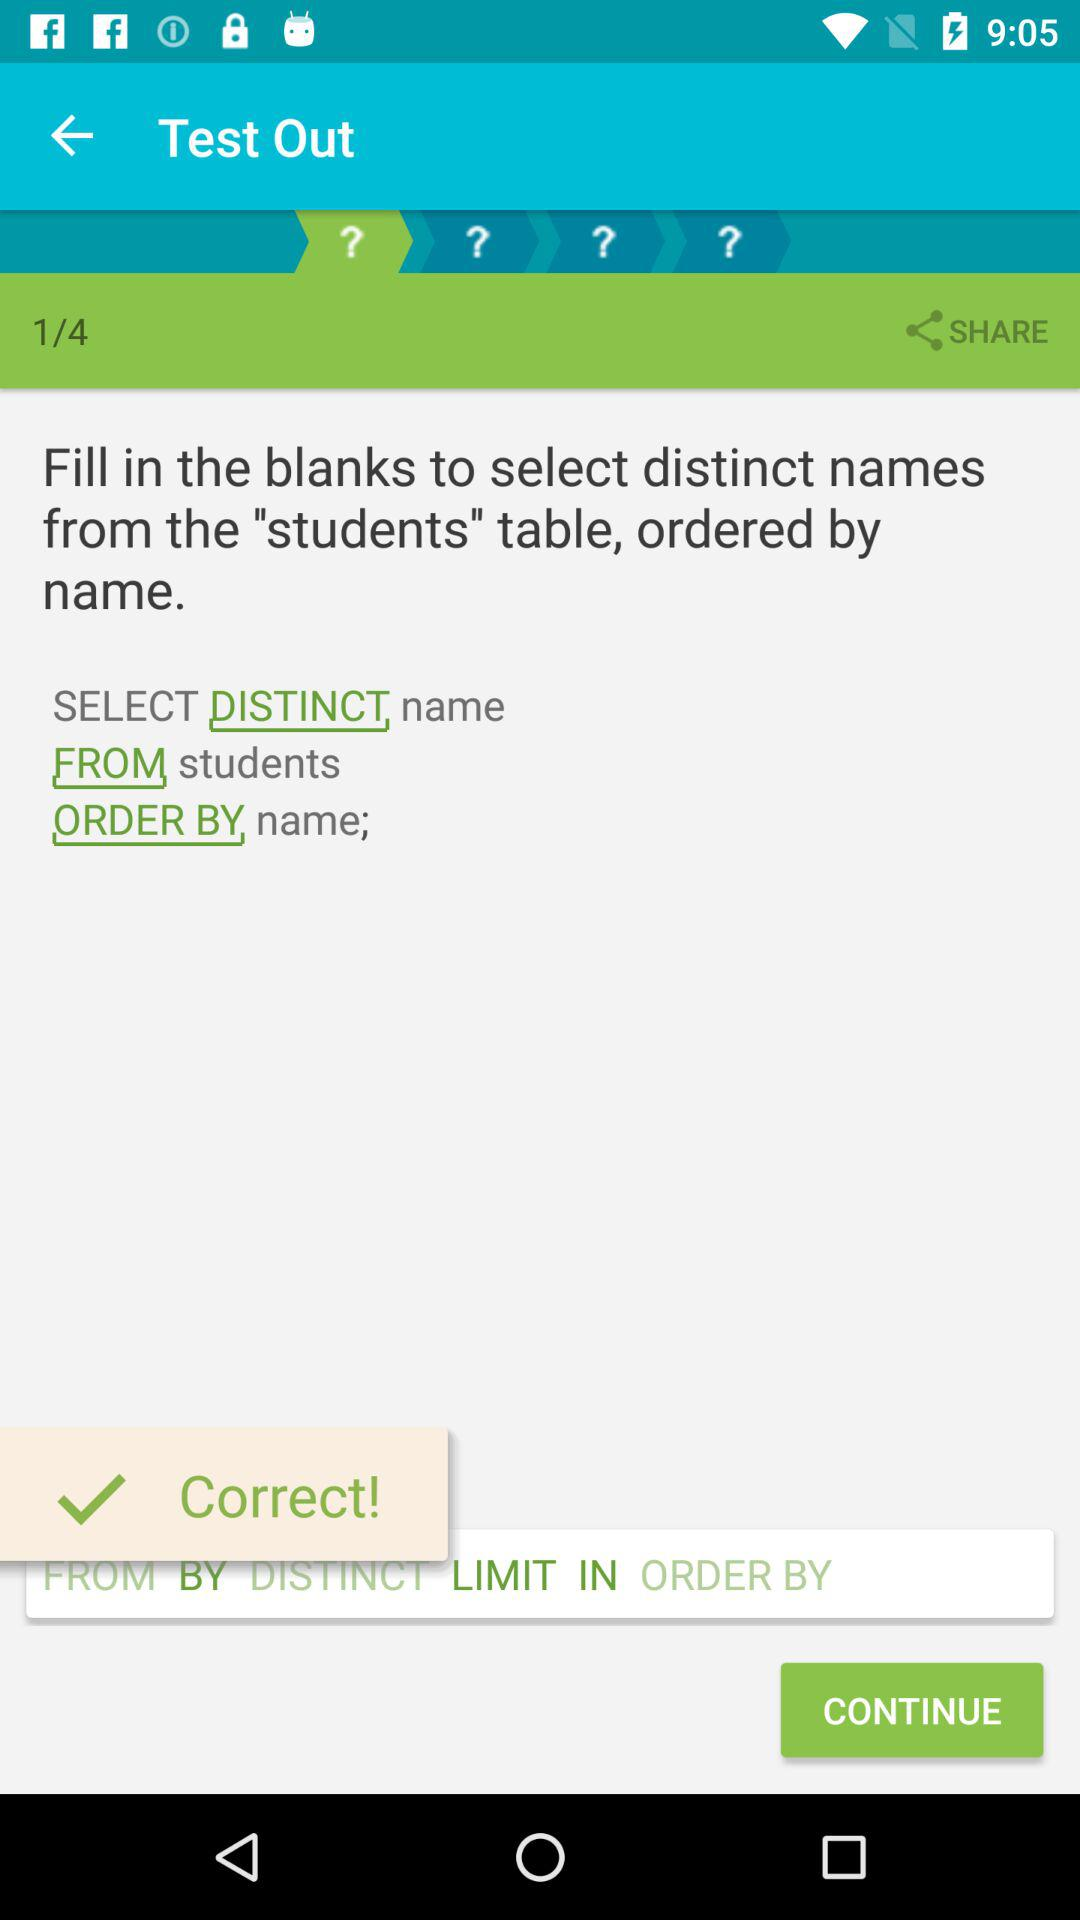How many tables are in the query?
Answer the question using a single word or phrase. 1 